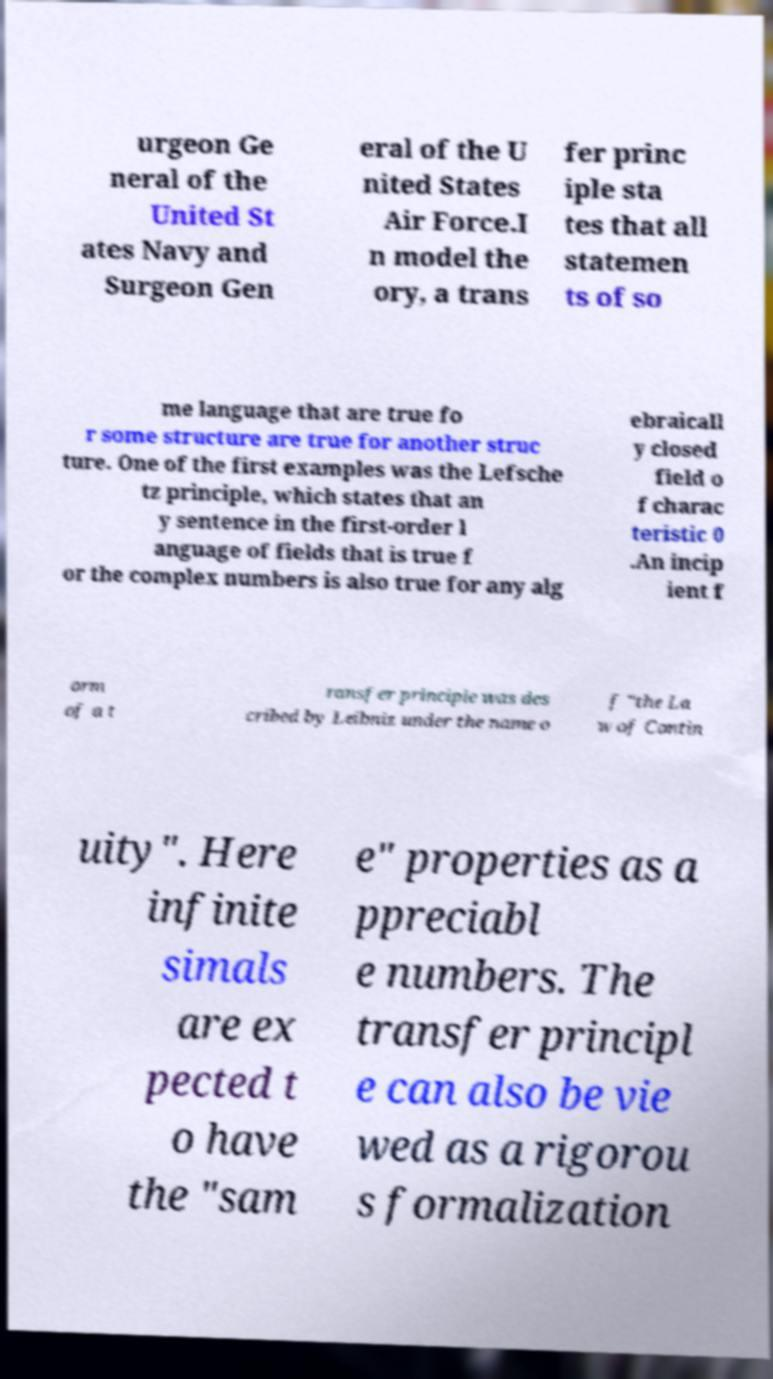Please identify and transcribe the text found in this image. urgeon Ge neral of the United St ates Navy and Surgeon Gen eral of the U nited States Air Force.I n model the ory, a trans fer princ iple sta tes that all statemen ts of so me language that are true fo r some structure are true for another struc ture. One of the first examples was the Lefsche tz principle, which states that an y sentence in the first-order l anguage of fields that is true f or the complex numbers is also true for any alg ebraicall y closed field o f charac teristic 0 .An incip ient f orm of a t ransfer principle was des cribed by Leibniz under the name o f "the La w of Contin uity". Here infinite simals are ex pected t o have the "sam e" properties as a ppreciabl e numbers. The transfer principl e can also be vie wed as a rigorou s formalization 